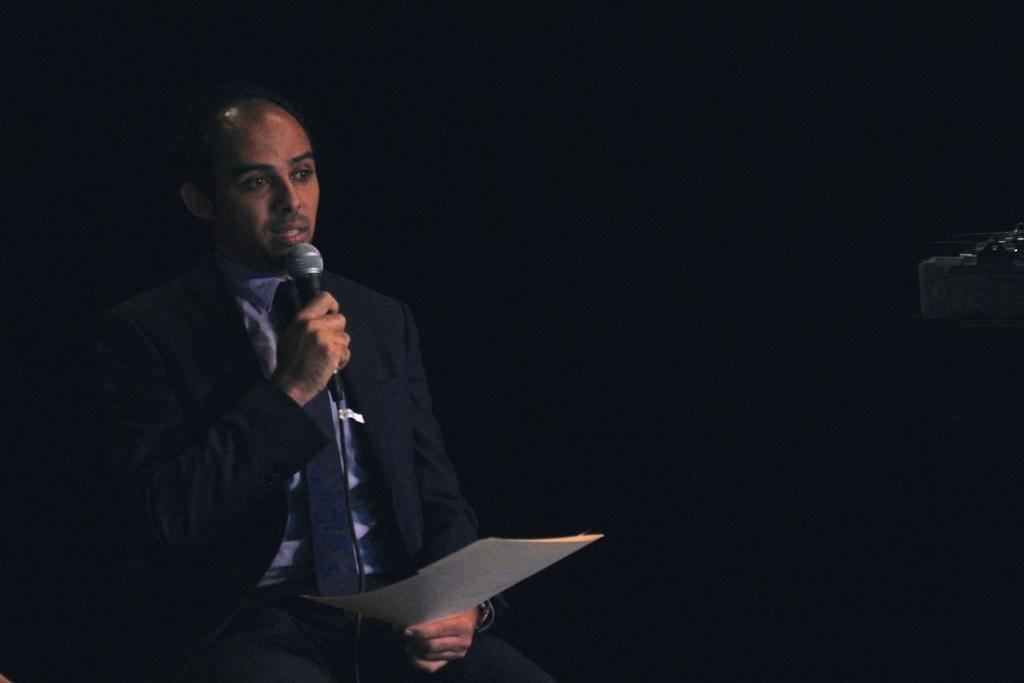Could you give a brief overview of what you see in this image? In this picture there is a person in black suit holding a mic in his right hand and a paper in left hand and sitting on the stool. 